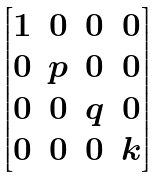<formula> <loc_0><loc_0><loc_500><loc_500>\begin{bmatrix} 1 & 0 & 0 & 0 \\ 0 & p & 0 & 0 \\ 0 & 0 & q & 0 \\ 0 & 0 & 0 & k \end{bmatrix}</formula> 